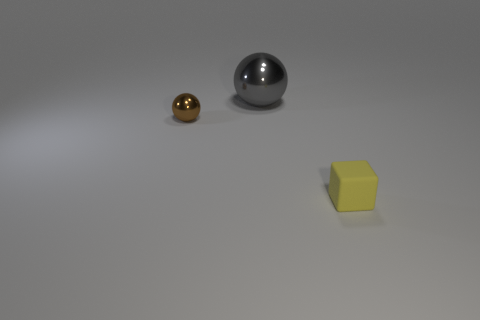There is a metal object that is behind the small thing that is behind the thing that is in front of the tiny metallic ball; what is its shape?
Make the answer very short. Sphere. There is a object behind the ball that is to the left of the large ball; what shape is it?
Your response must be concise. Sphere. Is there a yellow block that has the same material as the big ball?
Ensure brevity in your answer.  No. What number of green things are either big metal cubes or tiny shiny balls?
Provide a short and direct response. 0. Are there any rubber things that have the same color as the matte block?
Provide a short and direct response. No. What is the size of the sphere that is made of the same material as the tiny brown thing?
Provide a short and direct response. Large. What number of cylinders are metal things or green matte things?
Make the answer very short. 0. Are there more tiny metallic objects than tiny red rubber cylinders?
Your response must be concise. Yes. How many yellow matte blocks are the same size as the brown ball?
Ensure brevity in your answer.  1. How many objects are objects that are right of the small shiny ball or tiny brown balls?
Keep it short and to the point. 3. 